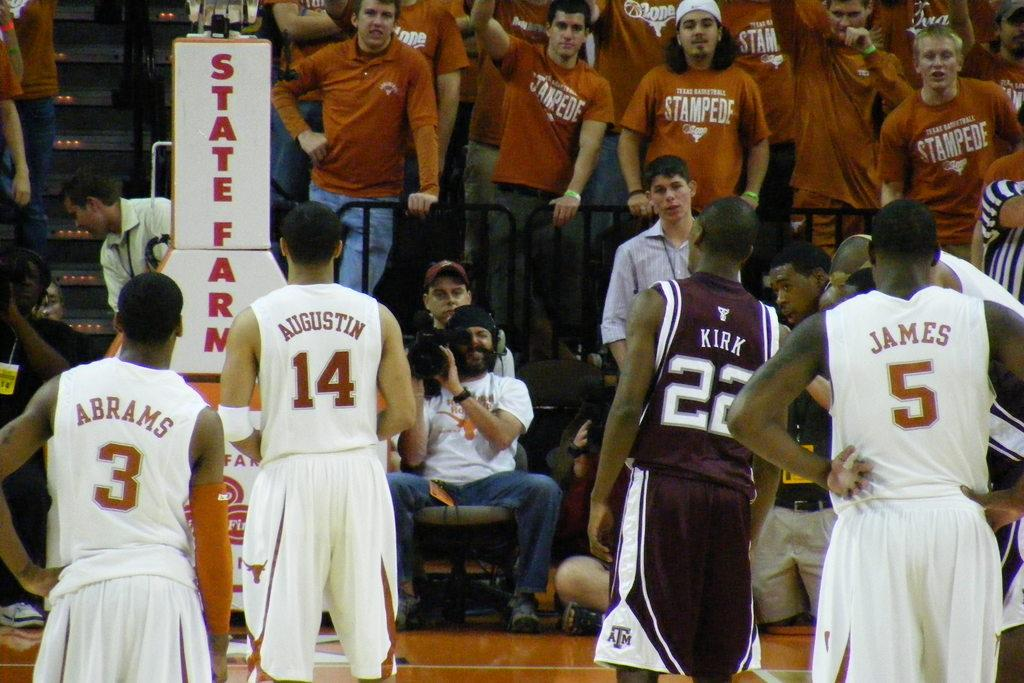<image>
Offer a succinct explanation of the picture presented. many players including one named James with the number 5 